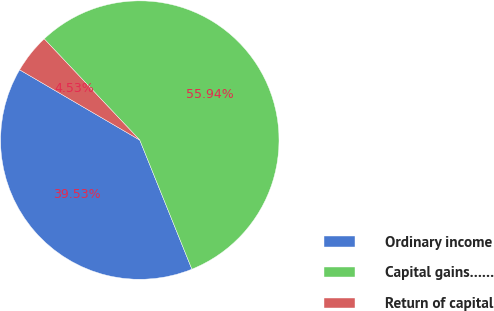<chart> <loc_0><loc_0><loc_500><loc_500><pie_chart><fcel>Ordinary income<fcel>Capital gains……<fcel>Return of capital<nl><fcel>39.53%<fcel>55.95%<fcel>4.53%<nl></chart> 